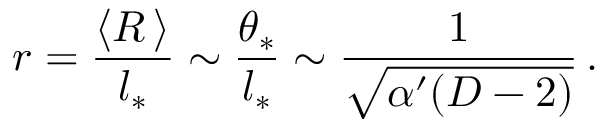Convert formula to latex. <formula><loc_0><loc_0><loc_500><loc_500>r = \frac { \langle R \, \rangle } { l _ { * } } \sim \frac { \theta _ { * } } { l _ { * } } \sim \frac { 1 } { \sqrt { \alpha ^ { \prime } ( D - 2 ) } } \, .</formula> 